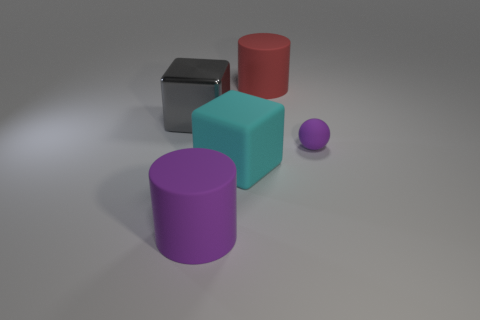Add 1 tiny purple balls. How many objects exist? 6 Subtract all cubes. How many objects are left? 3 Add 5 matte things. How many matte things are left? 9 Add 5 big purple cubes. How many big purple cubes exist? 5 Subtract 0 cyan spheres. How many objects are left? 5 Subtract all big cyan matte things. Subtract all large things. How many objects are left? 0 